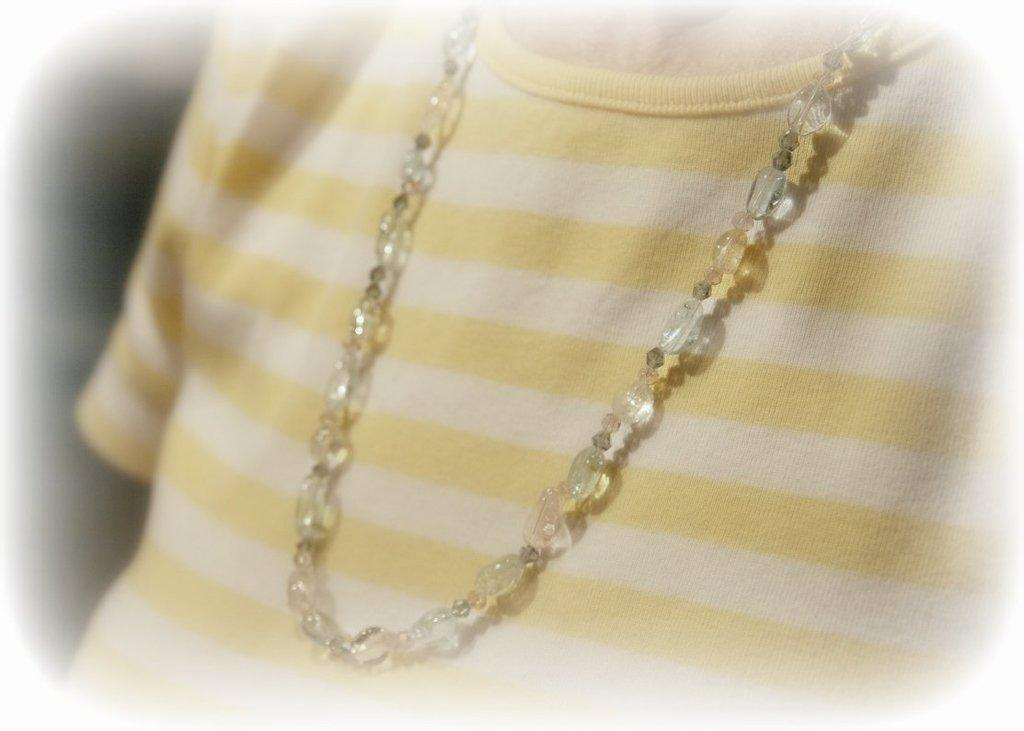Who or what is present in the image? There is a person in the image. What type of clothing is the person wearing? The person is wearing a T-shirt. Are there any accessories visible on the person? Yes, the person is wearing a beads necklace. How many feathers can be seen on the person's head in the image? There are no feathers visible on the person's head in the image. 